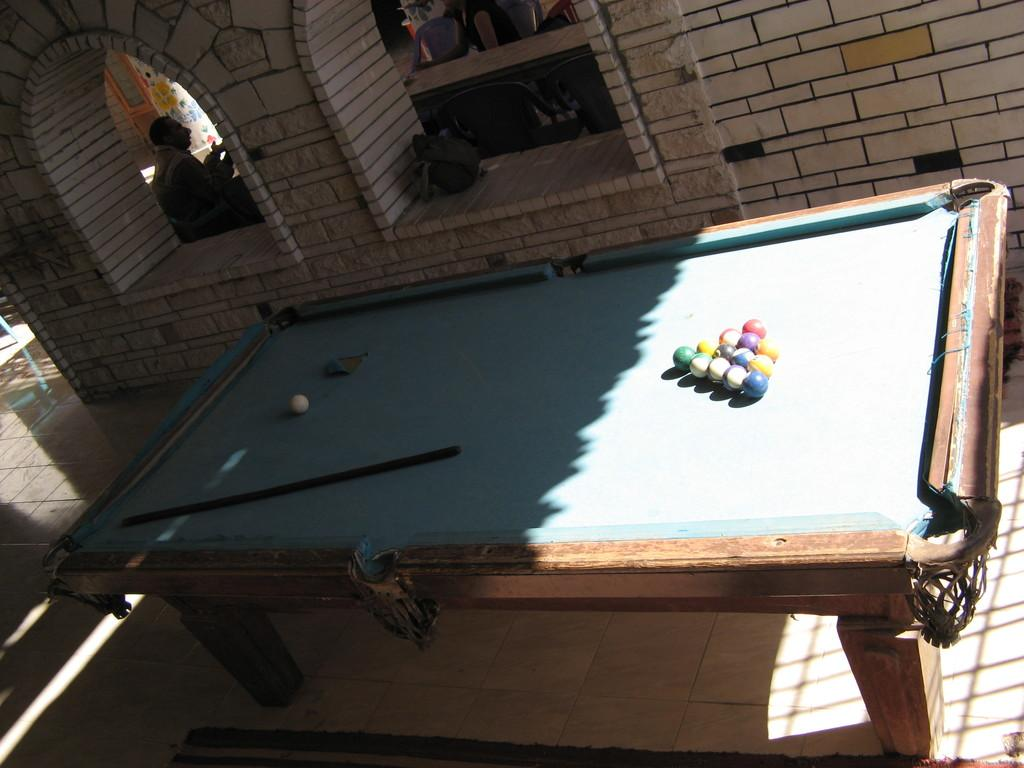What type of table is in the image? There is a snooker table in the image. What is on the snooker table? There are multi-color balls and a stick (cue) on the table. What else can be seen in the image? There are objects visible in the image, and a person is sitting. Where is the image taken? The inner part of a building is visible in the image. What type of wall is present in the image? There is a brick wall in the image. How many frogs are sitting on the snooker table in the image? There are no frogs present on the snooker table in the image. What type of pot is visible in the image? There is no pot visible in the image. 